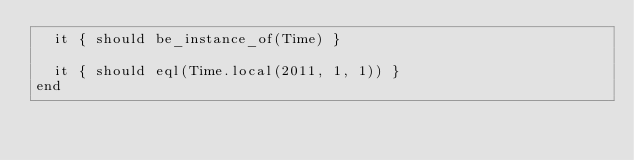Convert code to text. <code><loc_0><loc_0><loc_500><loc_500><_Ruby_>  it { should be_instance_of(Time) }

  it { should eql(Time.local(2011, 1, 1)) }
end
</code> 